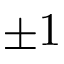<formula> <loc_0><loc_0><loc_500><loc_500>\pm 1</formula> 